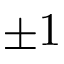<formula> <loc_0><loc_0><loc_500><loc_500>\pm 1</formula> 